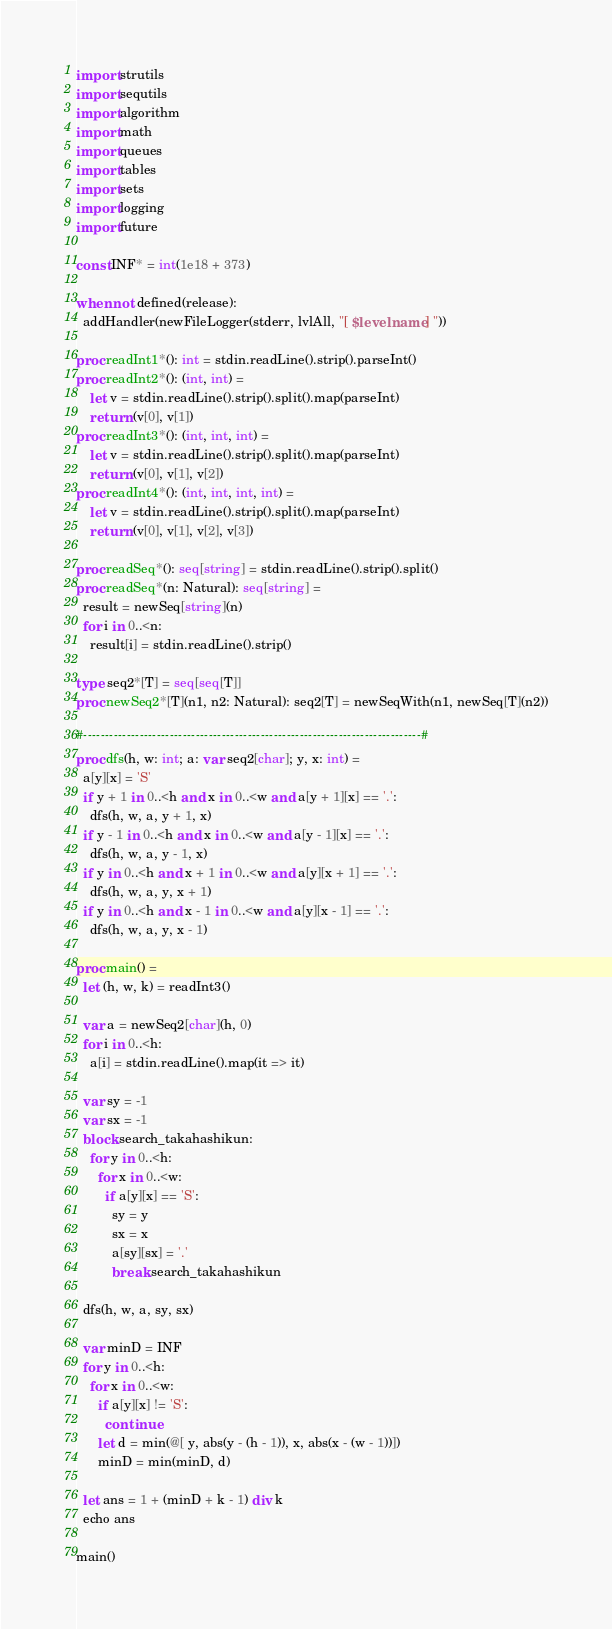<code> <loc_0><loc_0><loc_500><loc_500><_Nim_>import strutils
import sequtils
import algorithm
import math
import queues
import tables
import sets
import logging
import future

const INF* = int(1e18 + 373)

when not defined(release):
  addHandler(newFileLogger(stderr, lvlAll, "[ $levelname ] "))

proc readInt1*(): int = stdin.readLine().strip().parseInt()
proc readInt2*(): (int, int) =
    let v = stdin.readLine().strip().split().map(parseInt)
    return (v[0], v[1])
proc readInt3*(): (int, int, int) =
    let v = stdin.readLine().strip().split().map(parseInt)
    return (v[0], v[1], v[2])
proc readInt4*(): (int, int, int, int) =
    let v = stdin.readLine().strip().split().map(parseInt)
    return (v[0], v[1], v[2], v[3])

proc readSeq*(): seq[string] = stdin.readLine().strip().split()
proc readSeq*(n: Natural): seq[string] =
  result = newSeq[string](n)
  for i in 0..<n:
    result[i] = stdin.readLine().strip()

type seq2*[T] = seq[seq[T]]
proc newSeq2*[T](n1, n2: Natural): seq2[T] = newSeqWith(n1, newSeq[T](n2))

#------------------------------------------------------------------------------#
proc dfs(h, w: int; a: var seq2[char]; y, x: int) =
  a[y][x] = 'S'
  if y + 1 in 0..<h and x in 0..<w and a[y + 1][x] == '.':
    dfs(h, w, a, y + 1, x)
  if y - 1 in 0..<h and x in 0..<w and a[y - 1][x] == '.':
    dfs(h, w, a, y - 1, x)
  if y in 0..<h and x + 1 in 0..<w and a[y][x + 1] == '.':
    dfs(h, w, a, y, x + 1)
  if y in 0..<h and x - 1 in 0..<w and a[y][x - 1] == '.':
    dfs(h, w, a, y, x - 1)

proc main() =
  let (h, w, k) = readInt3()

  var a = newSeq2[char](h, 0)
  for i in 0..<h:
    a[i] = stdin.readLine().map(it => it)

  var sy = -1
  var sx = -1
  block search_takahashikun:
    for y in 0..<h:
      for x in 0..<w:
        if a[y][x] == 'S':
          sy = y
          sx = x
          a[sy][sx] = '.'
          break search_takahashikun

  dfs(h, w, a, sy, sx)

  var minD = INF
  for y in 0..<h:
    for x in 0..<w:
      if a[y][x] != 'S':
        continue
      let d = min(@[ y, abs(y - (h - 1)), x, abs(x - (w - 1))])
      minD = min(minD, d)

  let ans = 1 + (minD + k - 1) div k
  echo ans

main()

</code> 